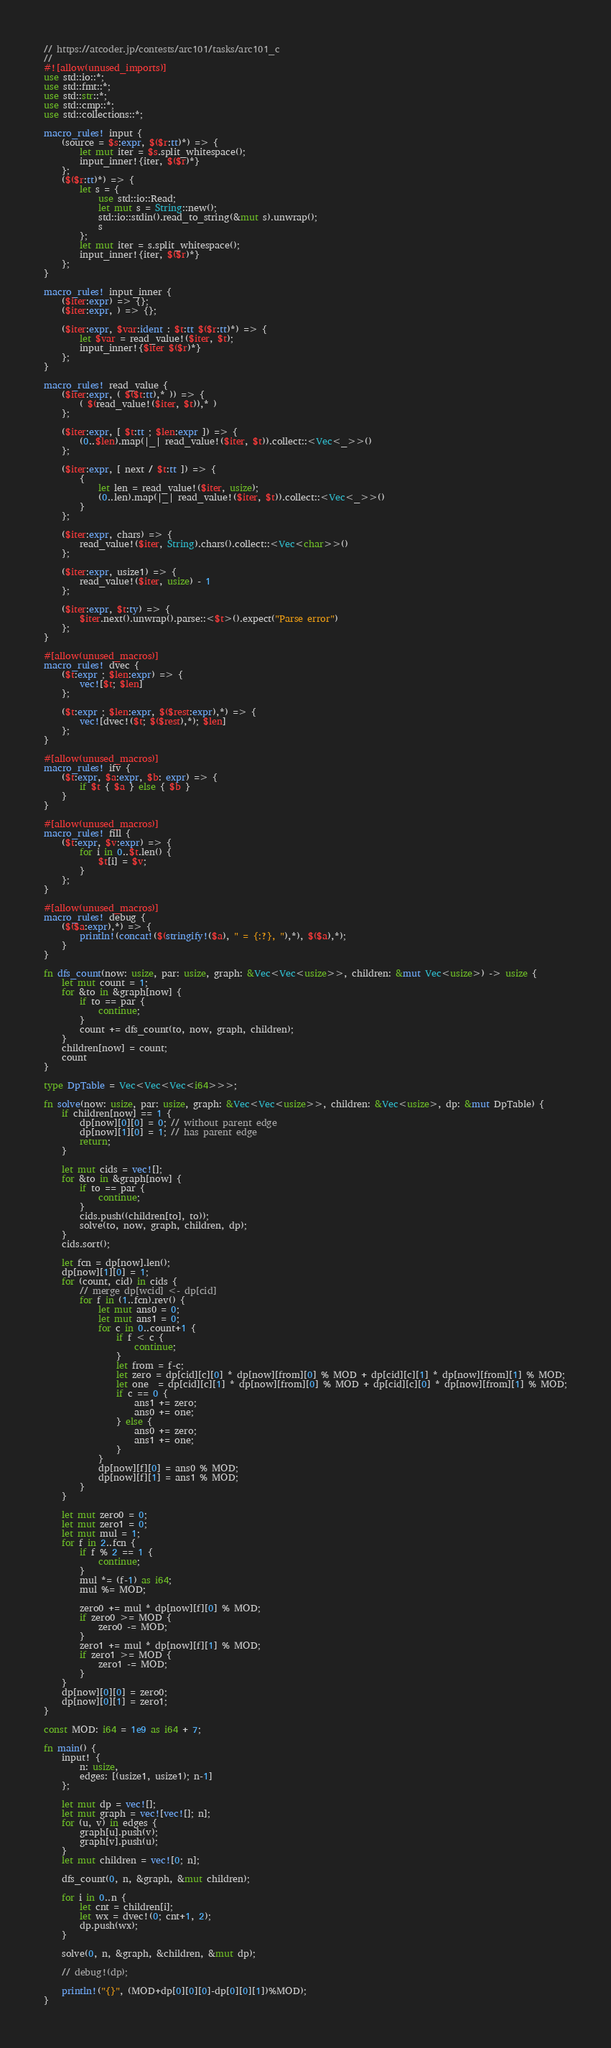Convert code to text. <code><loc_0><loc_0><loc_500><loc_500><_Rust_>// https://atcoder.jp/contests/arc101/tasks/arc101_c
//
#![allow(unused_imports)]
use std::io::*;
use std::fmt::*;
use std::str::*;
use std::cmp::*;
use std::collections::*;

macro_rules! input {
    (source = $s:expr, $($r:tt)*) => {
        let mut iter = $s.split_whitespace();
        input_inner!{iter, $($r)*}
    };
    ($($r:tt)*) => {
        let s = {
            use std::io::Read;
            let mut s = String::new();
            std::io::stdin().read_to_string(&mut s).unwrap();
            s
        };
        let mut iter = s.split_whitespace();
        input_inner!{iter, $($r)*}
    };
}

macro_rules! input_inner {
    ($iter:expr) => {};
    ($iter:expr, ) => {};

    ($iter:expr, $var:ident : $t:tt $($r:tt)*) => {
        let $var = read_value!($iter, $t);
        input_inner!{$iter $($r)*}
    };
}

macro_rules! read_value {
    ($iter:expr, ( $($t:tt),* )) => {
        ( $(read_value!($iter, $t)),* )
    };

    ($iter:expr, [ $t:tt ; $len:expr ]) => {
        (0..$len).map(|_| read_value!($iter, $t)).collect::<Vec<_>>()
    };

    ($iter:expr, [ next / $t:tt ]) => {
        {
            let len = read_value!($iter, usize);
            (0..len).map(|_| read_value!($iter, $t)).collect::<Vec<_>>()
        }
    };

    ($iter:expr, chars) => {
        read_value!($iter, String).chars().collect::<Vec<char>>()
    };

    ($iter:expr, usize1) => {
        read_value!($iter, usize) - 1
    };

    ($iter:expr, $t:ty) => {
        $iter.next().unwrap().parse::<$t>().expect("Parse error")
    };
}

#[allow(unused_macros)]
macro_rules! dvec {
    ($t:expr ; $len:expr) => {
        vec![$t; $len]
    };

    ($t:expr ; $len:expr, $($rest:expr),*) => {
        vec![dvec!($t; $($rest),*); $len]
    };
}

#[allow(unused_macros)]
macro_rules! ifv {
    ($t:expr, $a:expr, $b: expr) => {
        if $t { $a } else { $b }
    }
}

#[allow(unused_macros)]
macro_rules! fill {
    ($t:expr, $v:expr) => {
        for i in 0..$t.len() {
            $t[i] = $v;
        }
    };
}

#[allow(unused_macros)]
macro_rules! debug {
    ($($a:expr),*) => {
        println!(concat!($(stringify!($a), " = {:?}, "),*), $($a),*);
    }
}

fn dfs_count(now: usize, par: usize, graph: &Vec<Vec<usize>>, children: &mut Vec<usize>) -> usize {
    let mut count = 1;
    for &to in &graph[now] {
        if to == par {
            continue;
        }
        count += dfs_count(to, now, graph, children);
    }
    children[now] = count;
    count
}

type DpTable = Vec<Vec<Vec<i64>>>;

fn solve(now: usize, par: usize, graph: &Vec<Vec<usize>>, children: &Vec<usize>, dp: &mut DpTable) {
    if children[now] == 1 {
        dp[now][0][0] = 0; // without parent edge
        dp[now][1][0] = 1; // has parent edge
        return;
    }

    let mut cids = vec![];
    for &to in &graph[now] {
        if to == par {
            continue;
        }
        cids.push((children[to], to));
        solve(to, now, graph, children, dp);
    }
    cids.sort();

    let fcn = dp[now].len();
    dp[now][1][0] = 1;
    for (count, cid) in cids {
        // merge dp[wcid] <- dp[cid]
        for f in (1..fcn).rev() {
            let mut ans0 = 0;
            let mut ans1 = 0;
            for c in 0..count+1 {
                if f < c {
                    continue;
                }
                let from = f-c;
                let zero = dp[cid][c][0] * dp[now][from][0] % MOD + dp[cid][c][1] * dp[now][from][1] % MOD;
                let one  = dp[cid][c][1] * dp[now][from][0] % MOD + dp[cid][c][0] * dp[now][from][1] % MOD;
                if c == 0 {
                    ans1 += zero;
                    ans0 += one;
                } else {
                    ans0 += zero;
                    ans1 += one;
                }
            }
            dp[now][f][0] = ans0 % MOD;
            dp[now][f][1] = ans1 % MOD;
        }
    }

    let mut zero0 = 0;
    let mut zero1 = 0;
    let mut mul = 1;
    for f in 2..fcn {
        if f % 2 == 1 {
            continue;
        }
        mul *= (f-1) as i64;
        mul %= MOD;

        zero0 += mul * dp[now][f][0] % MOD;
        if zero0 >= MOD {
            zero0 -= MOD;
        }
        zero1 += mul * dp[now][f][1] % MOD;
        if zero1 >= MOD {
            zero1 -= MOD;
        }
    }
    dp[now][0][0] = zero0;
    dp[now][0][1] = zero1;
}

const MOD: i64 = 1e9 as i64 + 7;

fn main() {
    input! {
        n: usize,
        edges: [(usize1, usize1); n-1]
    };

    let mut dp = vec![];
    let mut graph = vec![vec![]; n];
    for (u, v) in edges {
        graph[u].push(v);
        graph[v].push(u);
    }
    let mut children = vec![0; n];

    dfs_count(0, n, &graph, &mut children);

    for i in 0..n {
        let cnt = children[i];
        let wx = dvec!(0; cnt+1, 2);
        dp.push(wx);
    }

    solve(0, n, &graph, &children, &mut dp);

    // debug!(dp);

    println!("{}", (MOD+dp[0][0][0]-dp[0][0][1])%MOD);
}
</code> 